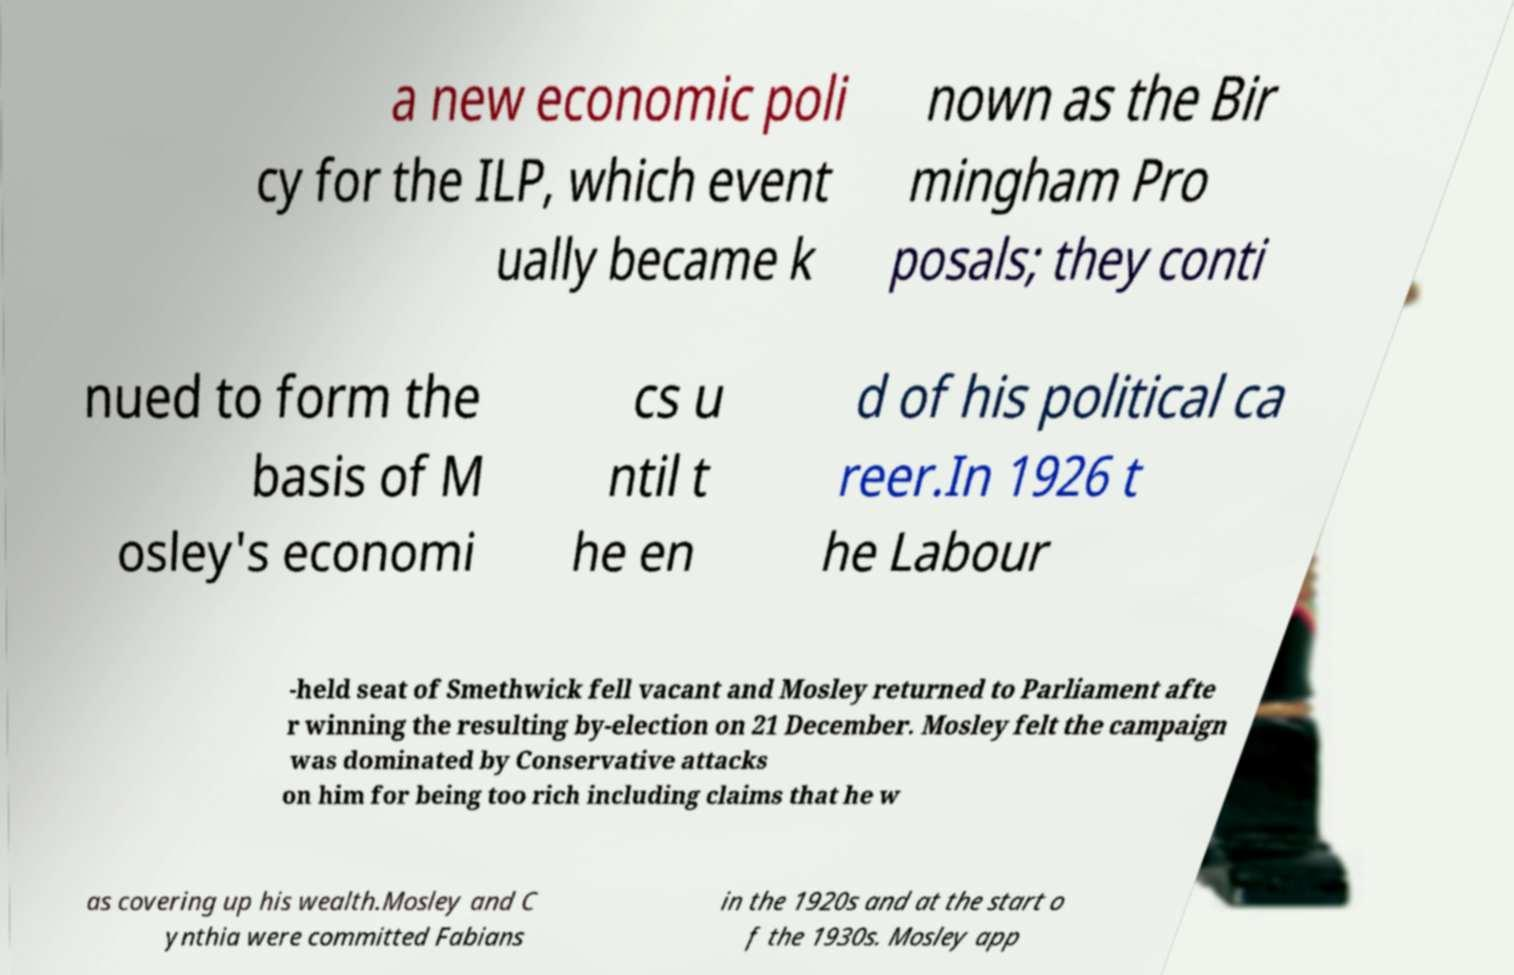Please identify and transcribe the text found in this image. a new economic poli cy for the ILP, which event ually became k nown as the Bir mingham Pro posals; they conti nued to form the basis of M osley's economi cs u ntil t he en d of his political ca reer.In 1926 t he Labour -held seat of Smethwick fell vacant and Mosley returned to Parliament afte r winning the resulting by-election on 21 December. Mosley felt the campaign was dominated by Conservative attacks on him for being too rich including claims that he w as covering up his wealth.Mosley and C ynthia were committed Fabians in the 1920s and at the start o f the 1930s. Mosley app 